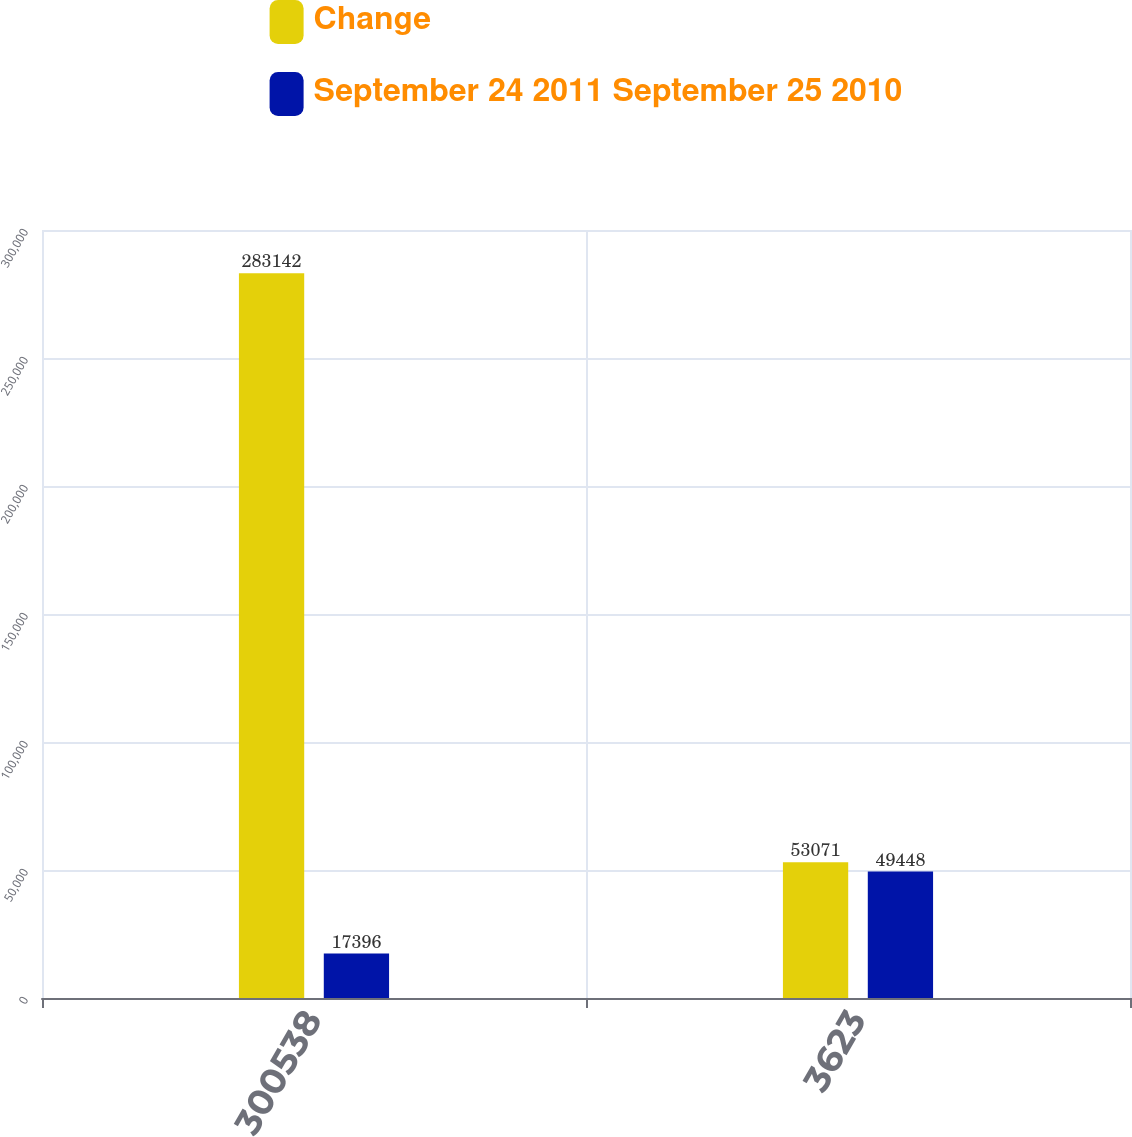Convert chart to OTSL. <chart><loc_0><loc_0><loc_500><loc_500><stacked_bar_chart><ecel><fcel>300538<fcel>3623<nl><fcel>Change<fcel>283142<fcel>53071<nl><fcel>September 24 2011 September 25 2010<fcel>17396<fcel>49448<nl></chart> 